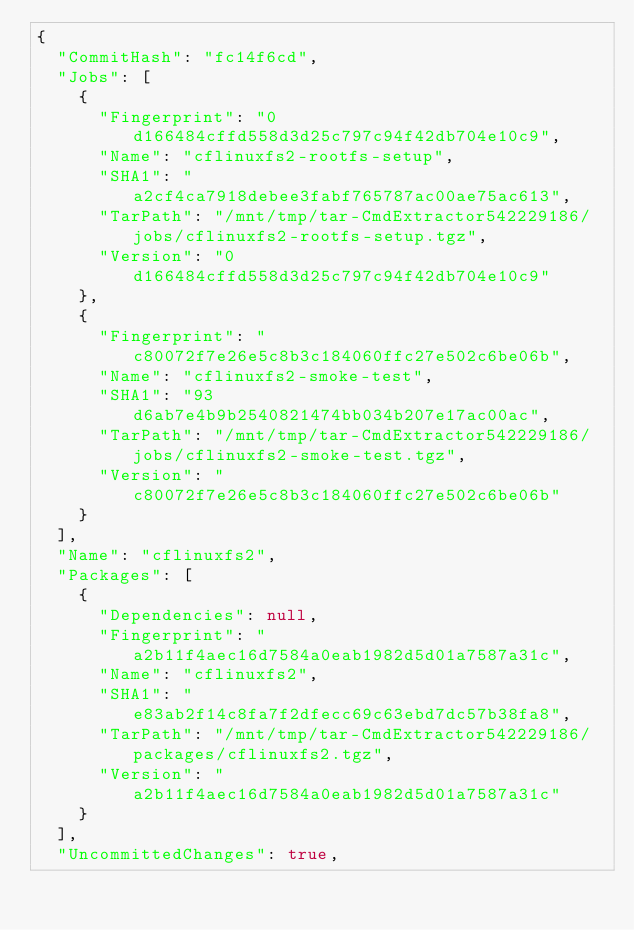Convert code to text. <code><loc_0><loc_0><loc_500><loc_500><_YAML_>{
  "CommitHash": "fc14f6cd",
  "Jobs": [
    {
      "Fingerprint": "0d166484cffd558d3d25c797c94f42db704e10c9",
      "Name": "cflinuxfs2-rootfs-setup",
      "SHA1": "a2cf4ca7918debee3fabf765787ac00ae75ac613",
      "TarPath": "/mnt/tmp/tar-CmdExtractor542229186/jobs/cflinuxfs2-rootfs-setup.tgz",
      "Version": "0d166484cffd558d3d25c797c94f42db704e10c9"
    },
    {
      "Fingerprint": "c80072f7e26e5c8b3c184060ffc27e502c6be06b",
      "Name": "cflinuxfs2-smoke-test",
      "SHA1": "93d6ab7e4b9b2540821474bb034b207e17ac00ac",
      "TarPath": "/mnt/tmp/tar-CmdExtractor542229186/jobs/cflinuxfs2-smoke-test.tgz",
      "Version": "c80072f7e26e5c8b3c184060ffc27e502c6be06b"
    }
  ],
  "Name": "cflinuxfs2",
  "Packages": [
    {
      "Dependencies": null,
      "Fingerprint": "a2b11f4aec16d7584a0eab1982d5d01a7587a31c",
      "Name": "cflinuxfs2",
      "SHA1": "e83ab2f14c8fa7f2dfecc69c63ebd7dc57b38fa8",
      "TarPath": "/mnt/tmp/tar-CmdExtractor542229186/packages/cflinuxfs2.tgz",
      "Version": "a2b11f4aec16d7584a0eab1982d5d01a7587a31c"
    }
  ],
  "UncommittedChanges": true,</code> 